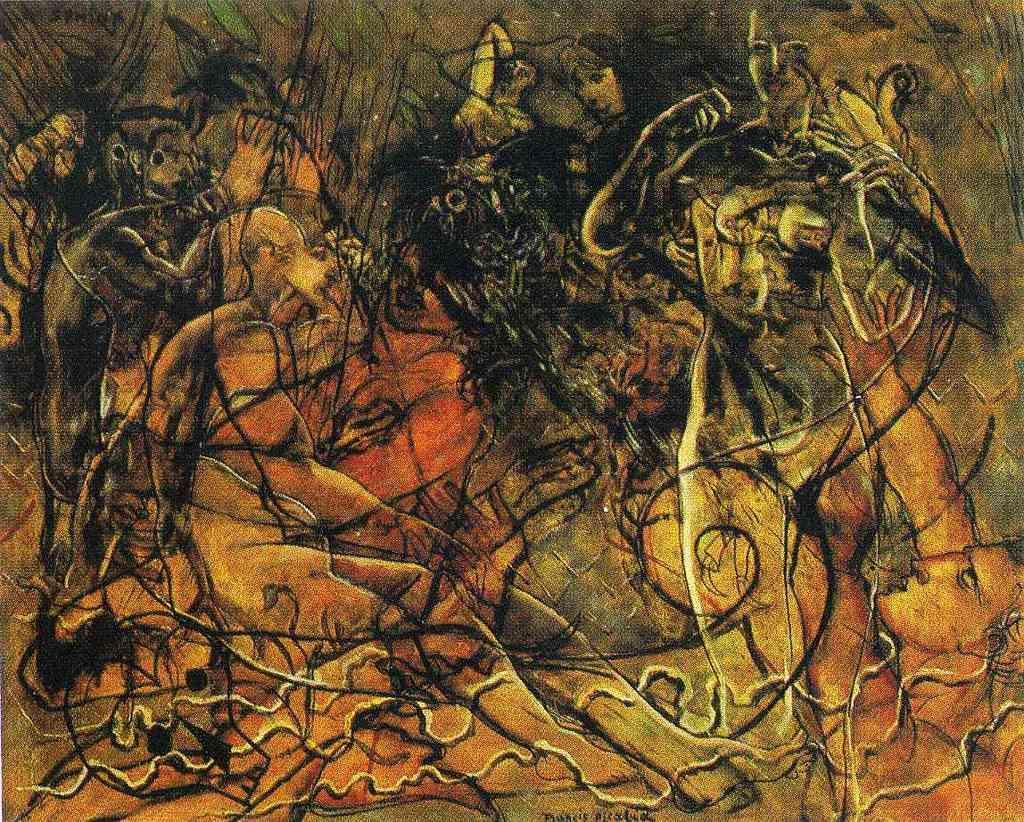How would you summarize this image in a sentence or two? Here we can see drawings of few people,trees and some other designs in it. 